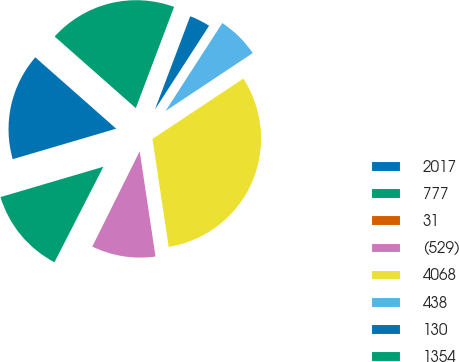Convert chart. <chart><loc_0><loc_0><loc_500><loc_500><pie_chart><fcel>2017<fcel>777<fcel>31<fcel>(529)<fcel>4068<fcel>438<fcel>130<fcel>1354<nl><fcel>16.07%<fcel>12.9%<fcel>0.19%<fcel>9.72%<fcel>31.96%<fcel>6.54%<fcel>3.37%<fcel>19.25%<nl></chart> 